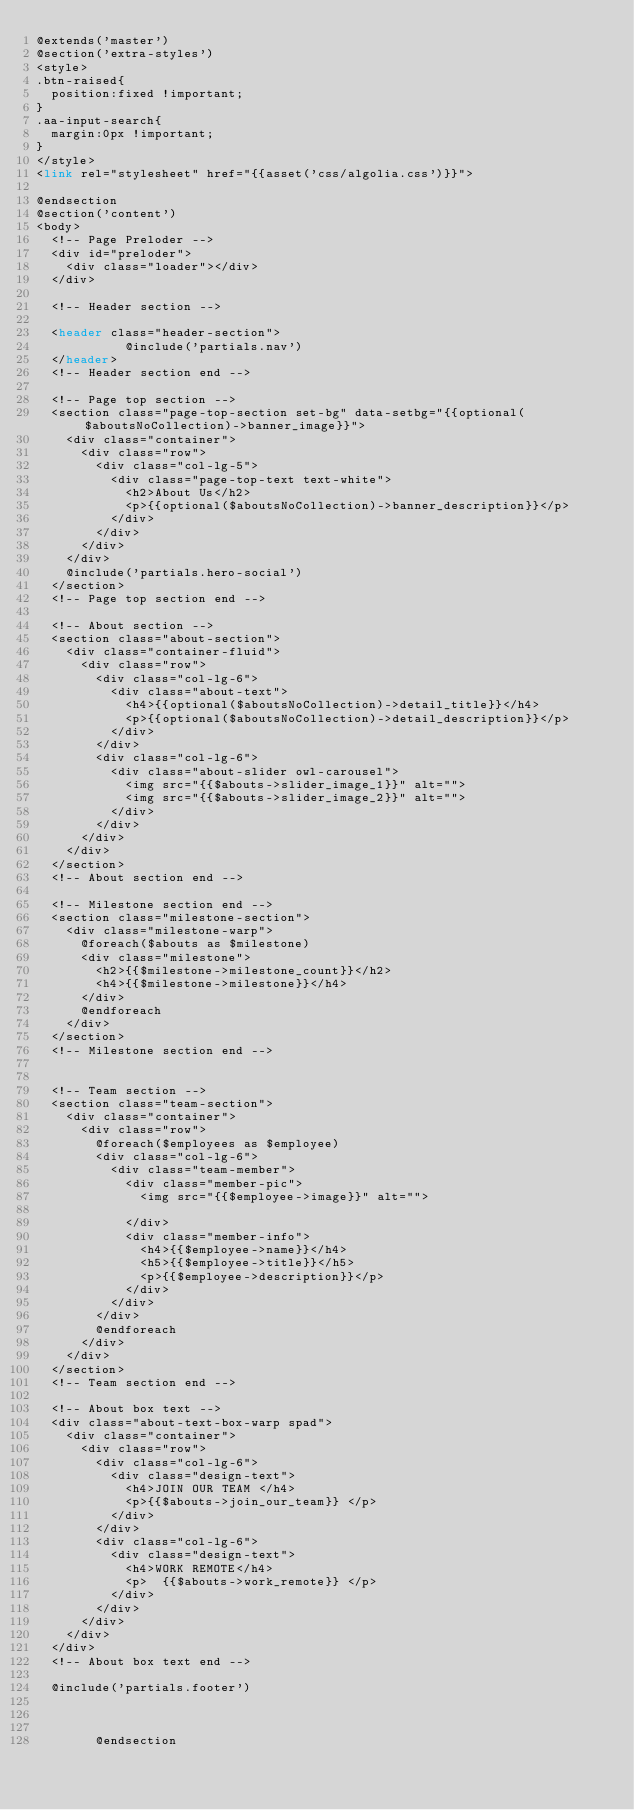<code> <loc_0><loc_0><loc_500><loc_500><_PHP_>@extends('master')
@section('extra-styles')
<style>
.btn-raised{
	position:fixed !important;
}
.aa-input-search{
	margin:0px !important;
}
</style>
<link rel="stylesheet" href="{{asset('css/algolia.css')}}">

@endsection
@section('content')
<body>
	<!-- Page Preloder -->
	<div id="preloder">
		<div class="loader"></div>
	</div>
	
	<!-- Header section -->
   
	<header class="header-section">
            @include('partials.nav')
	</header>
	<!-- Header section end -->
	
	<!-- Page top section -->
	<section class="page-top-section set-bg" data-setbg="{{optional($aboutsNoCollection)->banner_image}}">
		<div class="container">
			<div class="row">
				<div class="col-lg-5">
					<div class="page-top-text text-white">
						<h2>About Us</h2>
						<p>{{optional($aboutsNoCollection)->banner_description}}</p>
					</div>
				</div>
			</div>
		</div>
		@include('partials.hero-social')
	</section>
	<!-- Page top section end -->

	<!-- About section -->
	<section class="about-section">
		<div class="container-fluid">
			<div class="row">
				<div class="col-lg-6">
					<div class="about-text">
						<h4>{{optional($aboutsNoCollection)->detail_title}}</h4>
						<p>{{optional($aboutsNoCollection)->detail_description}}</p>
					</div>
				</div>
				<div class="col-lg-6">
					<div class="about-slider owl-carousel">
						<img src="{{$abouts->slider_image_1}}" alt="">
						<img src="{{$abouts->slider_image_2}}" alt="">
					</div>
				</div>
			</div>
		</div>
	</section>
	<!-- About section end -->
	
	<!-- Milestone section end -->
	<section class="milestone-section">
		<div class="milestone-warp">
			@foreach($abouts as $milestone)
			<div class="milestone">
				<h2>{{$milestone->milestone_count}}</h2>
				<h4>{{$milestone->milestone}}</h4>
			</div>
			@endforeach
		</div>
	</section>
	<!-- Milestone section end -->


	<!-- Team section -->
	<section class="team-section">
		<div class="container">
			<div class="row">
				@foreach($employees as $employee)
				<div class="col-lg-6">
					<div class="team-member">
						<div class="member-pic">
							<img src="{{$employee->image}}" alt="">
							
						</div>
						<div class="member-info">
							<h4>{{$employee->name}}</h4>
							<h5>{{$employee->title}}</h5>
							<p>{{$employee->description}}</p>
						</div>
					</div>
				</div>
				@endforeach
			</div>
		</div>
	</section>
	<!-- Team section end -->

	<!-- About box text -->
	<div class="about-text-box-warp spad">
		<div class="container">
			<div class="row">
				<div class="col-lg-6">
					<div class="design-text">
						<h4>JOIN OUR TEAM </h4>
						<p>{{$abouts->join_our_team}} </p>
					</div>
				</div>
				<div class="col-lg-6">
					<div class="design-text">
						<h4>WORK REMOTE</h4>
						<p>  {{$abouts->work_remote}} </p>
					</div>
				</div>
			</div>
		</div>
	</div>
	<!-- About box text end -->

	@include('partials.footer')

        

        @endsection</code> 